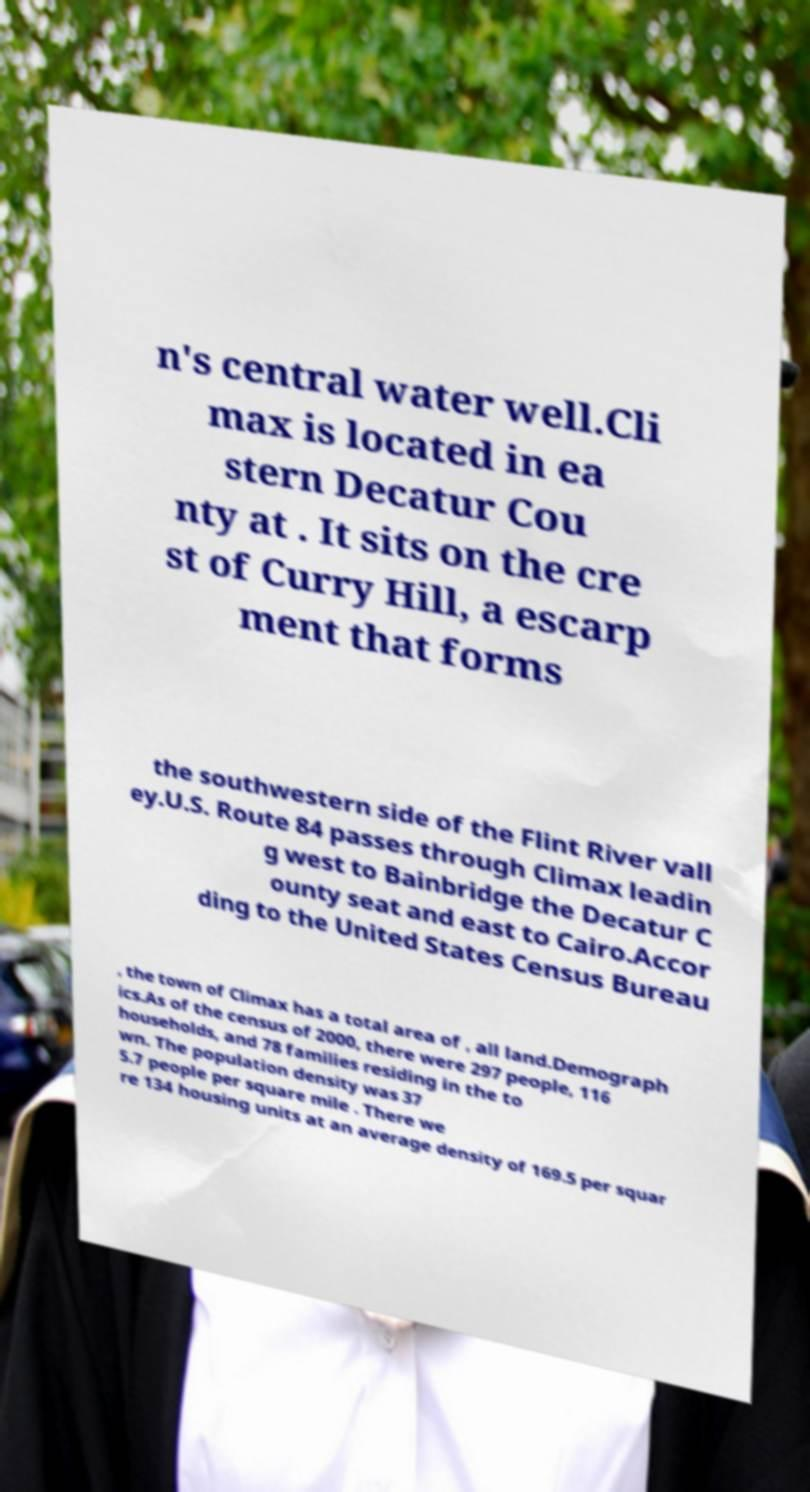Could you extract and type out the text from this image? n's central water well.Cli max is located in ea stern Decatur Cou nty at . It sits on the cre st of Curry Hill, a escarp ment that forms the southwestern side of the Flint River vall ey.U.S. Route 84 passes through Climax leadin g west to Bainbridge the Decatur C ounty seat and east to Cairo.Accor ding to the United States Census Bureau , the town of Climax has a total area of , all land.Demograph ics.As of the census of 2000, there were 297 people, 116 households, and 78 families residing in the to wn. The population density was 37 5.7 people per square mile . There we re 134 housing units at an average density of 169.5 per squar 